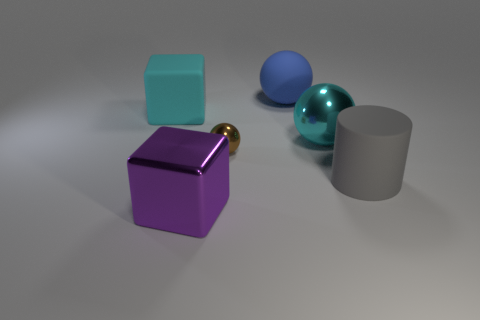Subtract all large blue balls. How many balls are left? 2 Add 4 large gray cylinders. How many objects exist? 10 Subtract all cyan spheres. How many spheres are left? 2 Subtract all blocks. How many objects are left? 4 Subtract 1 spheres. How many spheres are left? 2 Add 2 shiny blocks. How many shiny blocks exist? 3 Subtract 0 purple balls. How many objects are left? 6 Subtract all brown cylinders. Subtract all red cubes. How many cylinders are left? 1 Subtract all blue matte spheres. Subtract all metallic spheres. How many objects are left? 3 Add 6 tiny brown things. How many tiny brown things are left? 7 